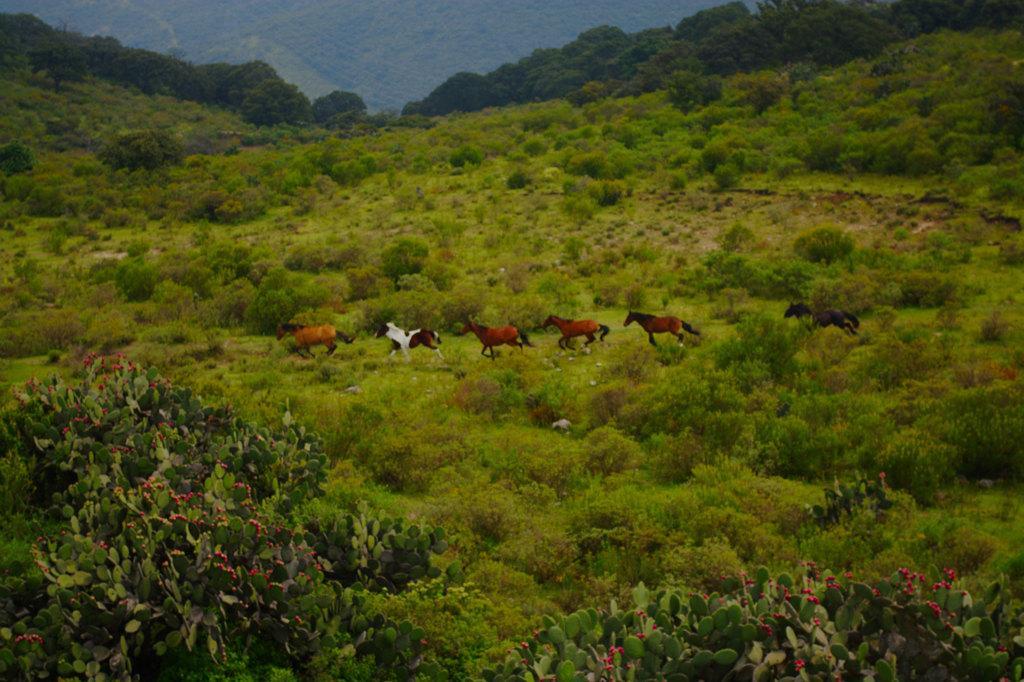Can you describe this image briefly? In this picture we can see some horses running, there are some plants and trees here, we can see flowers in the front. 